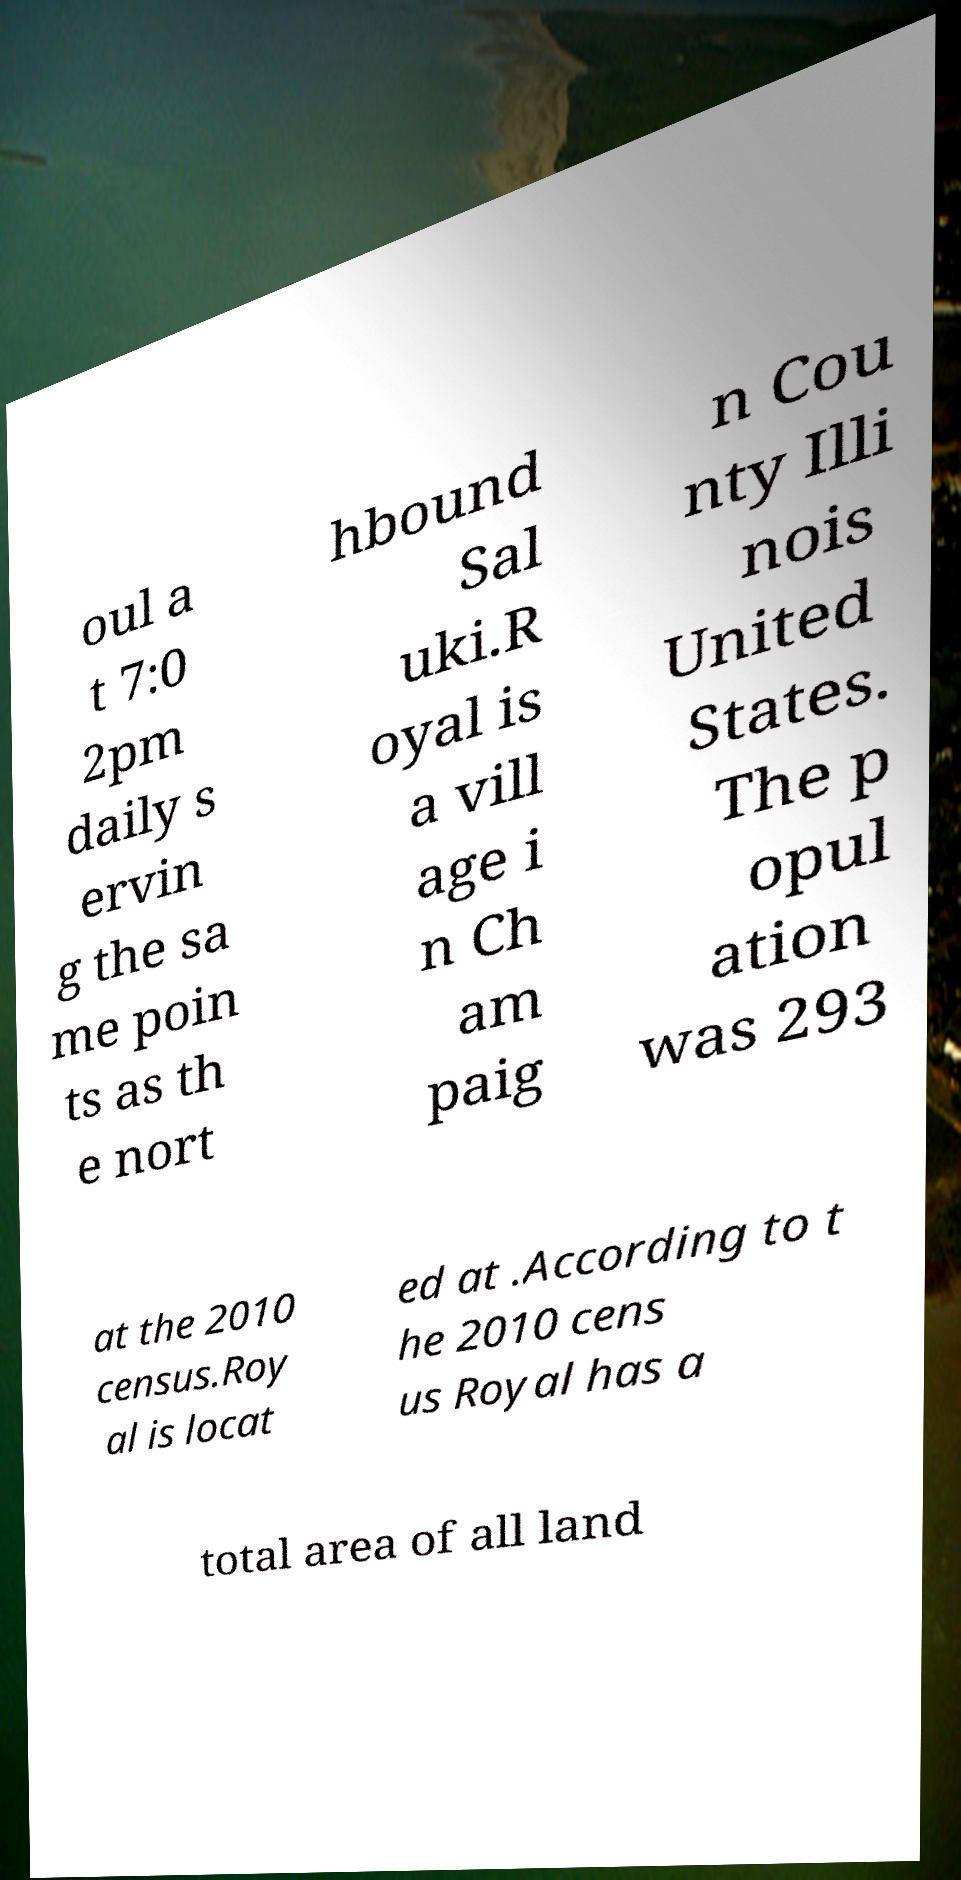Please identify and transcribe the text found in this image. oul a t 7:0 2pm daily s ervin g the sa me poin ts as th e nort hbound Sal uki.R oyal is a vill age i n Ch am paig n Cou nty Illi nois United States. The p opul ation was 293 at the 2010 census.Roy al is locat ed at .According to t he 2010 cens us Royal has a total area of all land 